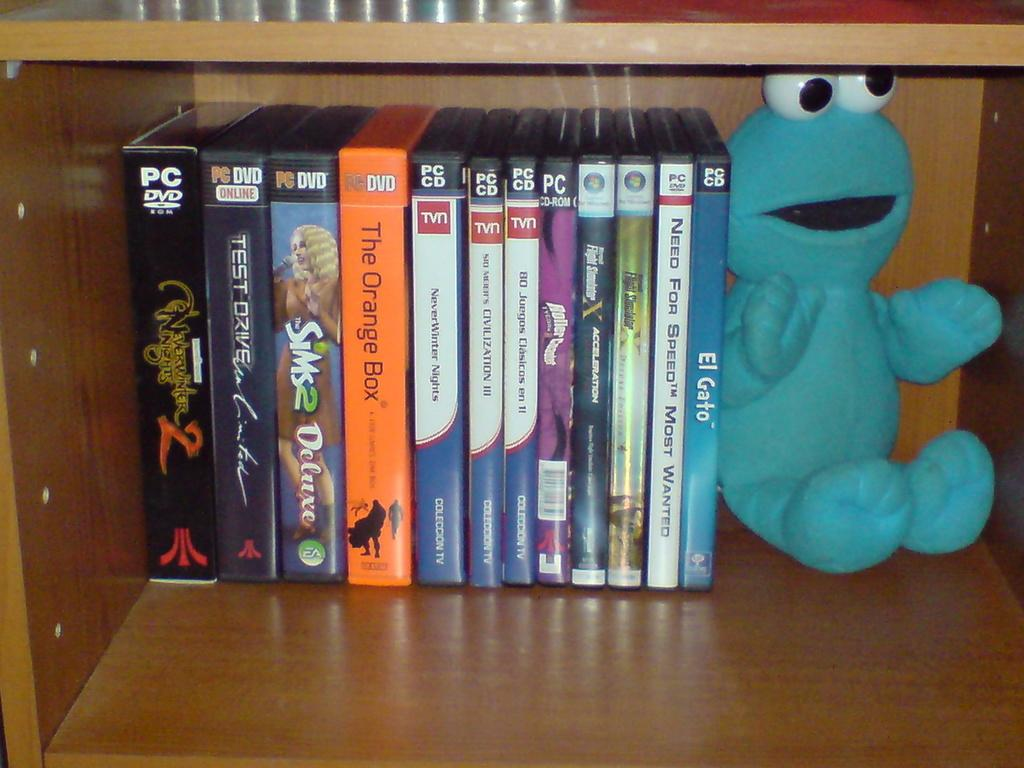<image>
Offer a succinct explanation of the picture presented. Several cases for discs including the Sims 2 Deluxe and El Gato are lined up neatly on a bookshelf. 